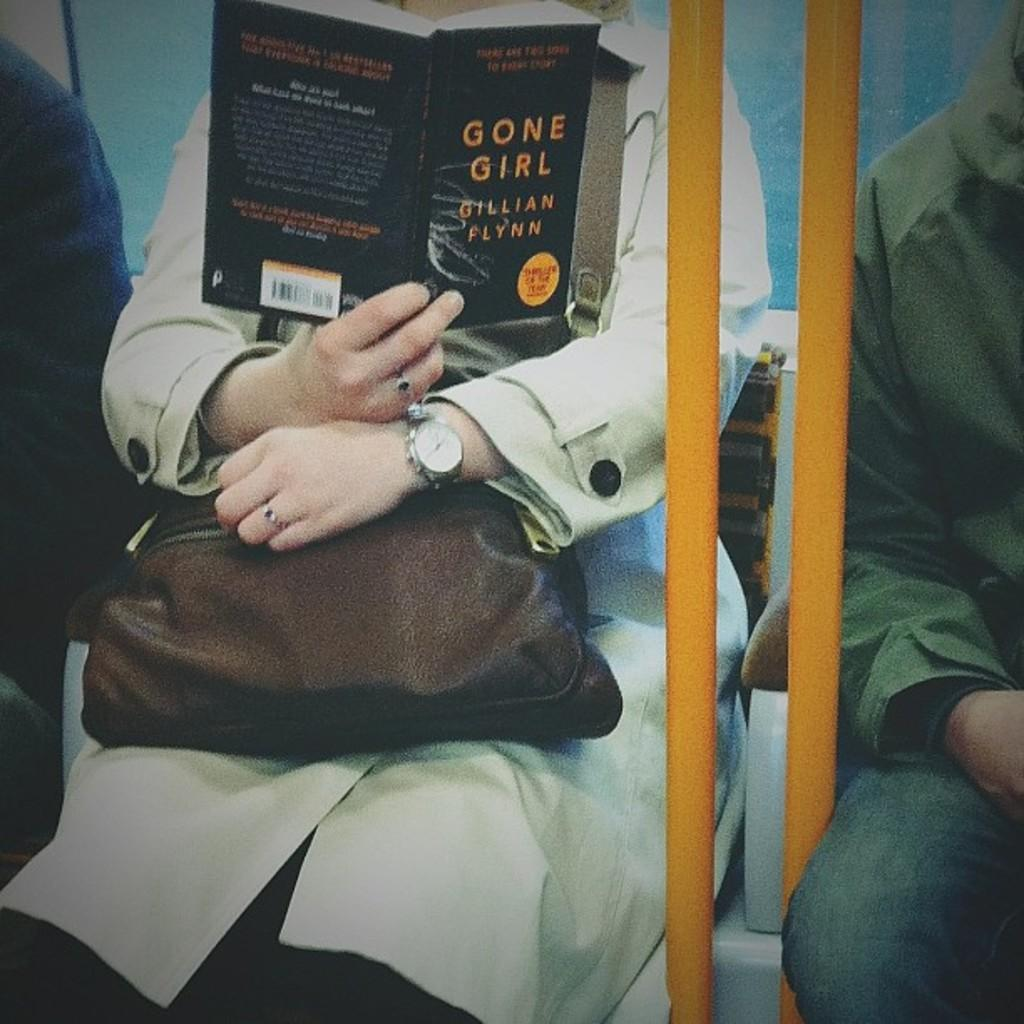<image>
Relay a brief, clear account of the picture shown. A woman sitting on public transportation while reading a copy of gone girl by gilian flynn. 